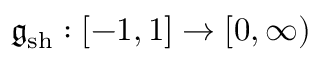<formula> <loc_0><loc_0><loc_500><loc_500>\mathfrak { g } _ { s h } \colon [ - 1 , 1 ] \to [ 0 , \infty )</formula> 